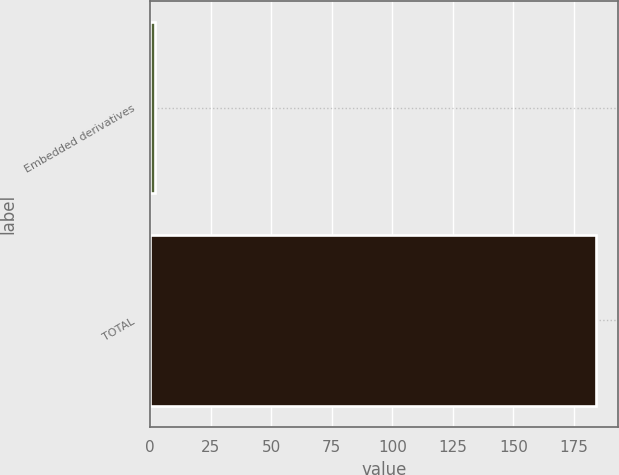<chart> <loc_0><loc_0><loc_500><loc_500><bar_chart><fcel>Embedded derivatives<fcel>TOTAL<nl><fcel>2<fcel>184<nl></chart> 